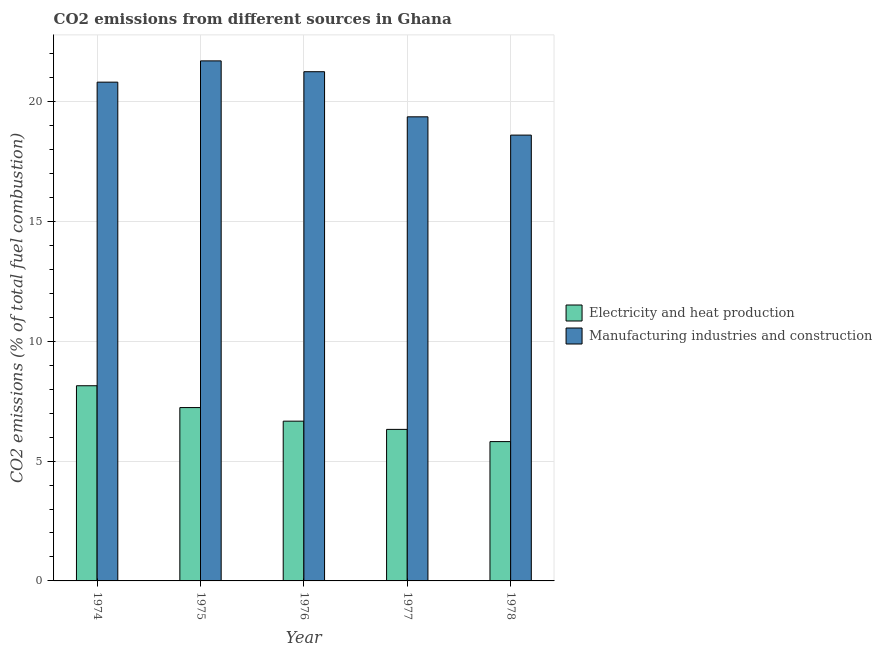Are the number of bars on each tick of the X-axis equal?
Offer a terse response. Yes. How many bars are there on the 3rd tick from the left?
Provide a succinct answer. 2. What is the label of the 5th group of bars from the left?
Your answer should be very brief. 1978. What is the co2 emissions due to manufacturing industries in 1974?
Provide a succinct answer. 20.81. Across all years, what is the maximum co2 emissions due to electricity and heat production?
Provide a short and direct response. 8.14. Across all years, what is the minimum co2 emissions due to manufacturing industries?
Ensure brevity in your answer.  18.6. In which year was the co2 emissions due to manufacturing industries maximum?
Your answer should be very brief. 1975. In which year was the co2 emissions due to electricity and heat production minimum?
Provide a short and direct response. 1978. What is the total co2 emissions due to manufacturing industries in the graph?
Your answer should be compact. 101.74. What is the difference between the co2 emissions due to manufacturing industries in 1974 and that in 1976?
Offer a terse response. -0.44. What is the difference between the co2 emissions due to electricity and heat production in 1976 and the co2 emissions due to manufacturing industries in 1974?
Provide a succinct answer. -1.48. What is the average co2 emissions due to manufacturing industries per year?
Offer a very short reply. 20.35. What is the ratio of the co2 emissions due to manufacturing industries in 1975 to that in 1977?
Your answer should be very brief. 1.12. What is the difference between the highest and the second highest co2 emissions due to electricity and heat production?
Give a very brief answer. 0.91. What is the difference between the highest and the lowest co2 emissions due to manufacturing industries?
Your answer should be compact. 3.1. What does the 1st bar from the left in 1974 represents?
Provide a short and direct response. Electricity and heat production. What does the 2nd bar from the right in 1974 represents?
Offer a very short reply. Electricity and heat production. What is the difference between two consecutive major ticks on the Y-axis?
Offer a very short reply. 5. Does the graph contain any zero values?
Offer a terse response. No. Where does the legend appear in the graph?
Ensure brevity in your answer.  Center right. How many legend labels are there?
Provide a short and direct response. 2. What is the title of the graph?
Offer a very short reply. CO2 emissions from different sources in Ghana. What is the label or title of the X-axis?
Provide a short and direct response. Year. What is the label or title of the Y-axis?
Offer a terse response. CO2 emissions (% of total fuel combustion). What is the CO2 emissions (% of total fuel combustion) of Electricity and heat production in 1974?
Offer a very short reply. 8.14. What is the CO2 emissions (% of total fuel combustion) in Manufacturing industries and construction in 1974?
Offer a terse response. 20.81. What is the CO2 emissions (% of total fuel combustion) of Electricity and heat production in 1975?
Your answer should be very brief. 7.23. What is the CO2 emissions (% of total fuel combustion) of Manufacturing industries and construction in 1975?
Give a very brief answer. 21.7. What is the CO2 emissions (% of total fuel combustion) of Electricity and heat production in 1976?
Offer a very short reply. 6.67. What is the CO2 emissions (% of total fuel combustion) in Manufacturing industries and construction in 1976?
Keep it short and to the point. 21.25. What is the CO2 emissions (% of total fuel combustion) of Electricity and heat production in 1977?
Provide a short and direct response. 6.32. What is the CO2 emissions (% of total fuel combustion) in Manufacturing industries and construction in 1977?
Offer a very short reply. 19.37. What is the CO2 emissions (% of total fuel combustion) of Electricity and heat production in 1978?
Provide a short and direct response. 5.81. What is the CO2 emissions (% of total fuel combustion) of Manufacturing industries and construction in 1978?
Make the answer very short. 18.6. Across all years, what is the maximum CO2 emissions (% of total fuel combustion) of Electricity and heat production?
Ensure brevity in your answer.  8.14. Across all years, what is the maximum CO2 emissions (% of total fuel combustion) of Manufacturing industries and construction?
Keep it short and to the point. 21.7. Across all years, what is the minimum CO2 emissions (% of total fuel combustion) in Electricity and heat production?
Provide a succinct answer. 5.81. Across all years, what is the minimum CO2 emissions (% of total fuel combustion) of Manufacturing industries and construction?
Make the answer very short. 18.6. What is the total CO2 emissions (% of total fuel combustion) in Electricity and heat production in the graph?
Provide a succinct answer. 34.18. What is the total CO2 emissions (% of total fuel combustion) of Manufacturing industries and construction in the graph?
Your response must be concise. 101.74. What is the difference between the CO2 emissions (% of total fuel combustion) of Electricity and heat production in 1974 and that in 1975?
Give a very brief answer. 0.91. What is the difference between the CO2 emissions (% of total fuel combustion) in Manufacturing industries and construction in 1974 and that in 1975?
Offer a very short reply. -0.89. What is the difference between the CO2 emissions (% of total fuel combustion) in Electricity and heat production in 1974 and that in 1976?
Your response must be concise. 1.48. What is the difference between the CO2 emissions (% of total fuel combustion) in Manufacturing industries and construction in 1974 and that in 1976?
Ensure brevity in your answer.  -0.44. What is the difference between the CO2 emissions (% of total fuel combustion) of Electricity and heat production in 1974 and that in 1977?
Give a very brief answer. 1.82. What is the difference between the CO2 emissions (% of total fuel combustion) of Manufacturing industries and construction in 1974 and that in 1977?
Provide a short and direct response. 1.45. What is the difference between the CO2 emissions (% of total fuel combustion) of Electricity and heat production in 1974 and that in 1978?
Offer a very short reply. 2.33. What is the difference between the CO2 emissions (% of total fuel combustion) in Manufacturing industries and construction in 1974 and that in 1978?
Your response must be concise. 2.21. What is the difference between the CO2 emissions (% of total fuel combustion) in Electricity and heat production in 1975 and that in 1976?
Your answer should be compact. 0.57. What is the difference between the CO2 emissions (% of total fuel combustion) of Manufacturing industries and construction in 1975 and that in 1976?
Your response must be concise. 0.45. What is the difference between the CO2 emissions (% of total fuel combustion) of Electricity and heat production in 1975 and that in 1977?
Give a very brief answer. 0.91. What is the difference between the CO2 emissions (% of total fuel combustion) of Manufacturing industries and construction in 1975 and that in 1977?
Your answer should be compact. 2.33. What is the difference between the CO2 emissions (% of total fuel combustion) of Electricity and heat production in 1975 and that in 1978?
Offer a terse response. 1.42. What is the difference between the CO2 emissions (% of total fuel combustion) in Manufacturing industries and construction in 1975 and that in 1978?
Make the answer very short. 3.1. What is the difference between the CO2 emissions (% of total fuel combustion) in Electricity and heat production in 1976 and that in 1977?
Provide a succinct answer. 0.34. What is the difference between the CO2 emissions (% of total fuel combustion) of Manufacturing industries and construction in 1976 and that in 1977?
Your answer should be very brief. 1.88. What is the difference between the CO2 emissions (% of total fuel combustion) of Electricity and heat production in 1976 and that in 1978?
Ensure brevity in your answer.  0.85. What is the difference between the CO2 emissions (% of total fuel combustion) in Manufacturing industries and construction in 1976 and that in 1978?
Your response must be concise. 2.65. What is the difference between the CO2 emissions (% of total fuel combustion) of Electricity and heat production in 1977 and that in 1978?
Ensure brevity in your answer.  0.51. What is the difference between the CO2 emissions (% of total fuel combustion) of Manufacturing industries and construction in 1977 and that in 1978?
Your answer should be compact. 0.76. What is the difference between the CO2 emissions (% of total fuel combustion) of Electricity and heat production in 1974 and the CO2 emissions (% of total fuel combustion) of Manufacturing industries and construction in 1975?
Your answer should be very brief. -13.56. What is the difference between the CO2 emissions (% of total fuel combustion) in Electricity and heat production in 1974 and the CO2 emissions (% of total fuel combustion) in Manufacturing industries and construction in 1976?
Your answer should be compact. -13.11. What is the difference between the CO2 emissions (% of total fuel combustion) in Electricity and heat production in 1974 and the CO2 emissions (% of total fuel combustion) in Manufacturing industries and construction in 1977?
Offer a very short reply. -11.22. What is the difference between the CO2 emissions (% of total fuel combustion) in Electricity and heat production in 1974 and the CO2 emissions (% of total fuel combustion) in Manufacturing industries and construction in 1978?
Your response must be concise. -10.46. What is the difference between the CO2 emissions (% of total fuel combustion) of Electricity and heat production in 1975 and the CO2 emissions (% of total fuel combustion) of Manufacturing industries and construction in 1976?
Ensure brevity in your answer.  -14.02. What is the difference between the CO2 emissions (% of total fuel combustion) of Electricity and heat production in 1975 and the CO2 emissions (% of total fuel combustion) of Manufacturing industries and construction in 1977?
Offer a very short reply. -12.13. What is the difference between the CO2 emissions (% of total fuel combustion) in Electricity and heat production in 1975 and the CO2 emissions (% of total fuel combustion) in Manufacturing industries and construction in 1978?
Give a very brief answer. -11.37. What is the difference between the CO2 emissions (% of total fuel combustion) in Electricity and heat production in 1976 and the CO2 emissions (% of total fuel combustion) in Manufacturing industries and construction in 1977?
Offer a very short reply. -12.7. What is the difference between the CO2 emissions (% of total fuel combustion) in Electricity and heat production in 1976 and the CO2 emissions (% of total fuel combustion) in Manufacturing industries and construction in 1978?
Your answer should be very brief. -11.94. What is the difference between the CO2 emissions (% of total fuel combustion) of Electricity and heat production in 1977 and the CO2 emissions (% of total fuel combustion) of Manufacturing industries and construction in 1978?
Your answer should be very brief. -12.28. What is the average CO2 emissions (% of total fuel combustion) of Electricity and heat production per year?
Provide a short and direct response. 6.84. What is the average CO2 emissions (% of total fuel combustion) of Manufacturing industries and construction per year?
Ensure brevity in your answer.  20.35. In the year 1974, what is the difference between the CO2 emissions (% of total fuel combustion) in Electricity and heat production and CO2 emissions (% of total fuel combustion) in Manufacturing industries and construction?
Offer a terse response. -12.67. In the year 1975, what is the difference between the CO2 emissions (% of total fuel combustion) of Electricity and heat production and CO2 emissions (% of total fuel combustion) of Manufacturing industries and construction?
Your answer should be compact. -14.47. In the year 1976, what is the difference between the CO2 emissions (% of total fuel combustion) in Electricity and heat production and CO2 emissions (% of total fuel combustion) in Manufacturing industries and construction?
Give a very brief answer. -14.58. In the year 1977, what is the difference between the CO2 emissions (% of total fuel combustion) in Electricity and heat production and CO2 emissions (% of total fuel combustion) in Manufacturing industries and construction?
Your answer should be compact. -13.04. In the year 1978, what is the difference between the CO2 emissions (% of total fuel combustion) of Electricity and heat production and CO2 emissions (% of total fuel combustion) of Manufacturing industries and construction?
Offer a terse response. -12.79. What is the ratio of the CO2 emissions (% of total fuel combustion) in Electricity and heat production in 1974 to that in 1975?
Keep it short and to the point. 1.13. What is the ratio of the CO2 emissions (% of total fuel combustion) of Manufacturing industries and construction in 1974 to that in 1975?
Offer a terse response. 0.96. What is the ratio of the CO2 emissions (% of total fuel combustion) in Electricity and heat production in 1974 to that in 1976?
Give a very brief answer. 1.22. What is the ratio of the CO2 emissions (% of total fuel combustion) in Manufacturing industries and construction in 1974 to that in 1976?
Your answer should be compact. 0.98. What is the ratio of the CO2 emissions (% of total fuel combustion) of Electricity and heat production in 1974 to that in 1977?
Your response must be concise. 1.29. What is the ratio of the CO2 emissions (% of total fuel combustion) of Manufacturing industries and construction in 1974 to that in 1977?
Give a very brief answer. 1.07. What is the ratio of the CO2 emissions (% of total fuel combustion) in Electricity and heat production in 1974 to that in 1978?
Offer a terse response. 1.4. What is the ratio of the CO2 emissions (% of total fuel combustion) of Manufacturing industries and construction in 1974 to that in 1978?
Give a very brief answer. 1.12. What is the ratio of the CO2 emissions (% of total fuel combustion) in Electricity and heat production in 1975 to that in 1976?
Keep it short and to the point. 1.09. What is the ratio of the CO2 emissions (% of total fuel combustion) of Manufacturing industries and construction in 1975 to that in 1976?
Your response must be concise. 1.02. What is the ratio of the CO2 emissions (% of total fuel combustion) of Electricity and heat production in 1975 to that in 1977?
Keep it short and to the point. 1.14. What is the ratio of the CO2 emissions (% of total fuel combustion) in Manufacturing industries and construction in 1975 to that in 1977?
Your answer should be compact. 1.12. What is the ratio of the CO2 emissions (% of total fuel combustion) of Electricity and heat production in 1975 to that in 1978?
Offer a terse response. 1.24. What is the ratio of the CO2 emissions (% of total fuel combustion) in Manufacturing industries and construction in 1975 to that in 1978?
Provide a succinct answer. 1.17. What is the ratio of the CO2 emissions (% of total fuel combustion) in Electricity and heat production in 1976 to that in 1977?
Provide a short and direct response. 1.05. What is the ratio of the CO2 emissions (% of total fuel combustion) in Manufacturing industries and construction in 1976 to that in 1977?
Your answer should be very brief. 1.1. What is the ratio of the CO2 emissions (% of total fuel combustion) in Electricity and heat production in 1976 to that in 1978?
Your response must be concise. 1.15. What is the ratio of the CO2 emissions (% of total fuel combustion) of Manufacturing industries and construction in 1976 to that in 1978?
Make the answer very short. 1.14. What is the ratio of the CO2 emissions (% of total fuel combustion) of Electricity and heat production in 1977 to that in 1978?
Make the answer very short. 1.09. What is the ratio of the CO2 emissions (% of total fuel combustion) of Manufacturing industries and construction in 1977 to that in 1978?
Keep it short and to the point. 1.04. What is the difference between the highest and the second highest CO2 emissions (% of total fuel combustion) of Electricity and heat production?
Offer a very short reply. 0.91. What is the difference between the highest and the second highest CO2 emissions (% of total fuel combustion) of Manufacturing industries and construction?
Your answer should be compact. 0.45. What is the difference between the highest and the lowest CO2 emissions (% of total fuel combustion) in Electricity and heat production?
Provide a short and direct response. 2.33. What is the difference between the highest and the lowest CO2 emissions (% of total fuel combustion) in Manufacturing industries and construction?
Your response must be concise. 3.1. 